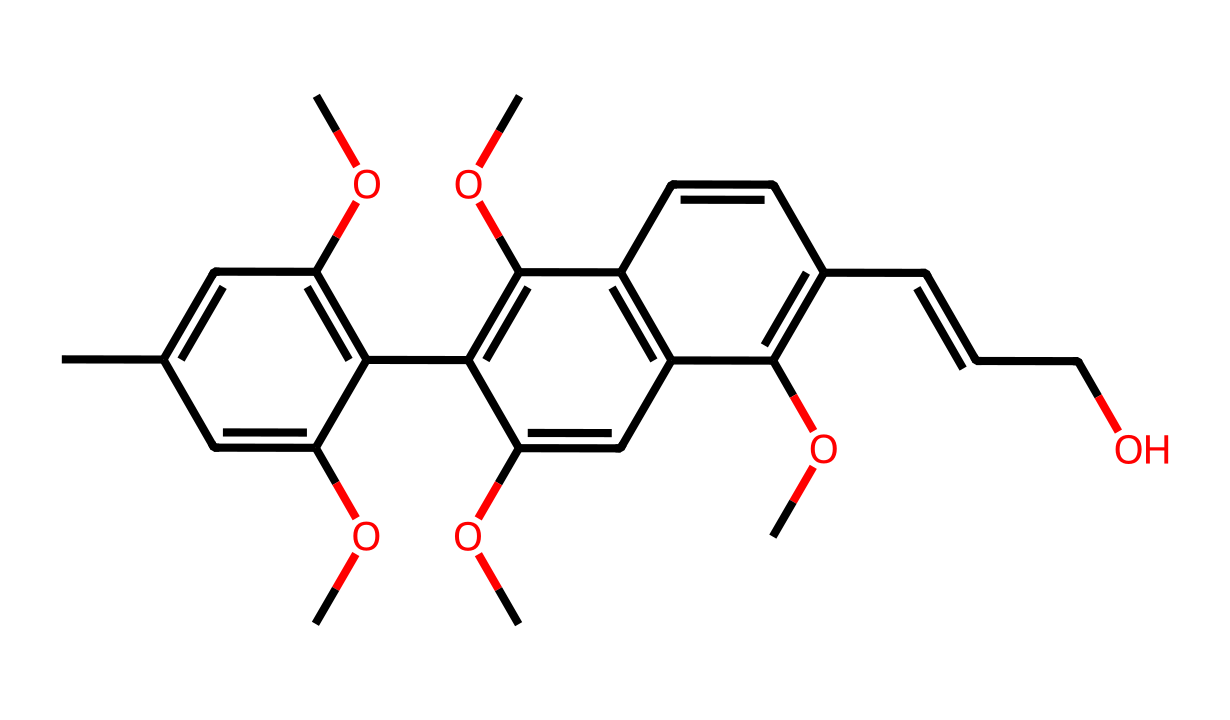What is the molecular formula represented by the SMILES? By translating the SMILES into its molecular components, we can count the number of each atom present: C (carbon), H (hydrogen), and O (oxygen). The structure indicates the presence of 28 carbons, 30 hydrogens, and 8 oxygens, leading to the molecular formula C28H30O8.
Answer: C28H30O8 How many rings are present in this chemical structure? Analyzing the SMILES, we note the presence of multiple carbon cycles forming aromatic rings. By counting these cycles, we find that there are three rings in total.
Answer: 3 What type of chemical bonding is predominant in the structure? Observing the molecular structure and the connectivity of atoms, we can determine that covalent bonds are most prevalent, particularly between carbon and hydrogen atoms as well as carbon and oxygen atoms throughout the compound.
Answer: covalent What functional groups can be identified in this chemical? By examining the structure, we can identify ether groups (–O–) due to the presence of oxygen atoms connecting carbon chains, and hydroxyl groups (–OH) indicating that there are phenolic structures within the lignin derivative.
Answer: ether and hydroxyl Which part of this structure contributes to photoreactivity? The extensive conjugated system in the aromatic rings and the presence of the ether functional groups contribute significantly to the photoreactive properties as they can absorb light and facilitate energy transitions.
Answer: conjugated system Is this chemical soluble in water? Considering the hydrophobic nature due to the high carbon content combined with some polar functional groups, it suggests partial solubility but mainly limited solubility in water.
Answer: partially soluble 